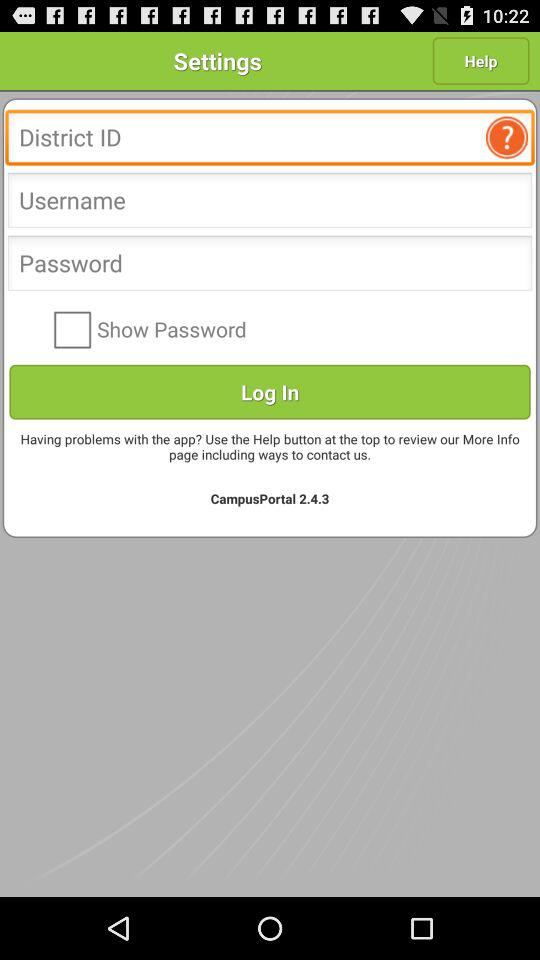Is "Show Password" checked or unchecked? "Show Password" is unchecked. 